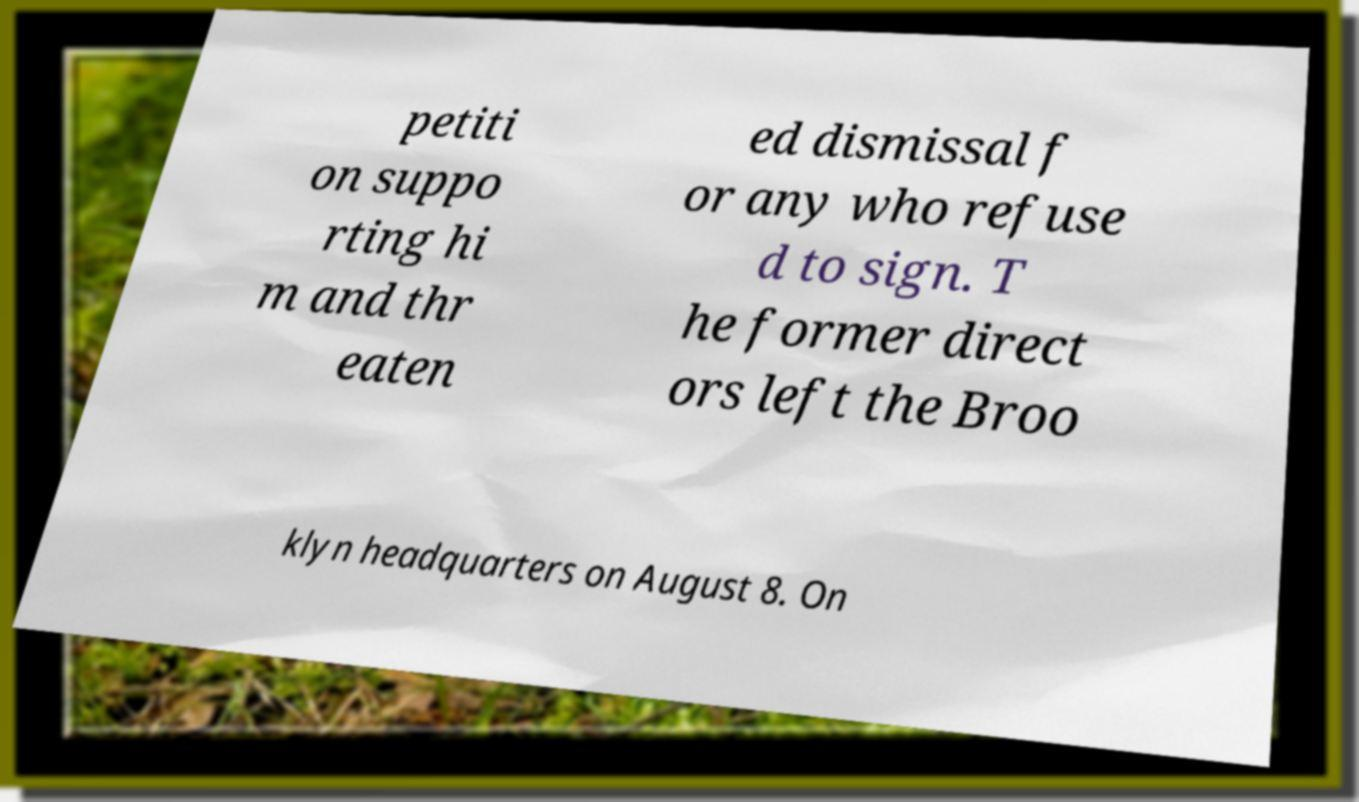I need the written content from this picture converted into text. Can you do that? petiti on suppo rting hi m and thr eaten ed dismissal f or any who refuse d to sign. T he former direct ors left the Broo klyn headquarters on August 8. On 